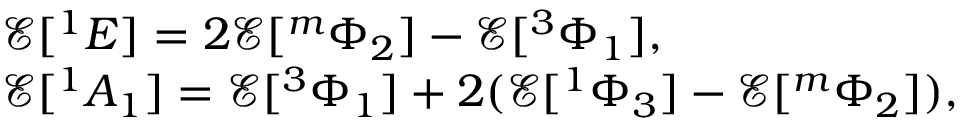<formula> <loc_0><loc_0><loc_500><loc_500>\begin{array} { r l } & { \mathcal { E } [ ^ { 1 } E ] = 2 \mathcal { E } [ ^ { m } \Phi _ { 2 } ] - \mathcal { E } [ ^ { 3 } \Phi _ { 1 } ] , } \\ & { \mathcal { E } [ ^ { 1 } A _ { 1 } ] = \mathcal { E } [ ^ { 3 } \Phi _ { 1 } ] + 2 ( \mathcal { E } [ ^ { 1 } \Phi _ { 3 } ] - \mathcal { E } [ ^ { m } \Phi _ { 2 } ] ) , } \end{array}</formula> 